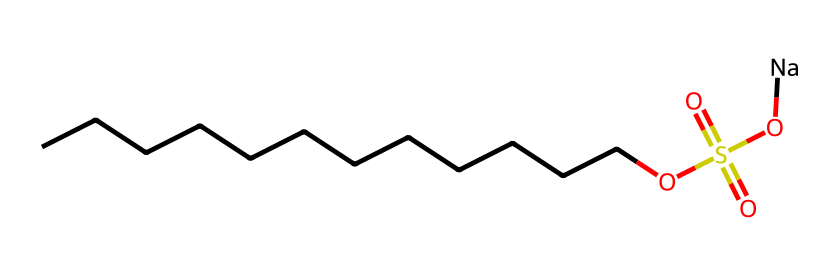What is the name of this chemical? The SMILES representation indicates that this chemical is sodium lauryl sulfate, as it includes the relevant alkyl chain (dodecane) and the sulfate group.
Answer: sodium lauryl sulfate How many carbon atoms are in the structure? The linear portion of the structure "CCCCCCCCCCCC" indicates there are twelve carbon atoms in the hydrocarbon chain.
Answer: twelve What is the total number of oxygen atoms? The structure shows two oxygen atoms in the sulfate group "OS(=O)(=O)" and one in the hydroxyl (-OH) part, giving a total of three oxygen atoms.
Answer: three What type of chemical is sodium lauryl sulfate? Sodium lauryl sulfate is classified as an anionic surfactant because of the sulfate group that carries a negative charge, which is key in its function in detergents.
Answer: anionic surfactant What property of sodium lauryl sulfate is related to the long carbon chain? The long carbon chain provides hydrophobic properties, allowing the molecule to interact with oils and grease, which is crucial for its role as a detergent.
Answer: hydrophobic properties What is the role of the sodium ion in this chemical? The sodium ion acts as a counterion, balancing the negative charge from the sulfate group, which makes the compound soluble in water while maintaining its detergent properties.
Answer: counterion Why does sodium lauryl sulfate create foam in detergents? The combination of the long hydrophobic carbon chain and the hydrophilic sulfate group allows it to reduce surface tension in water, leading to foam formation when agitated.
Answer: reduce surface tension 